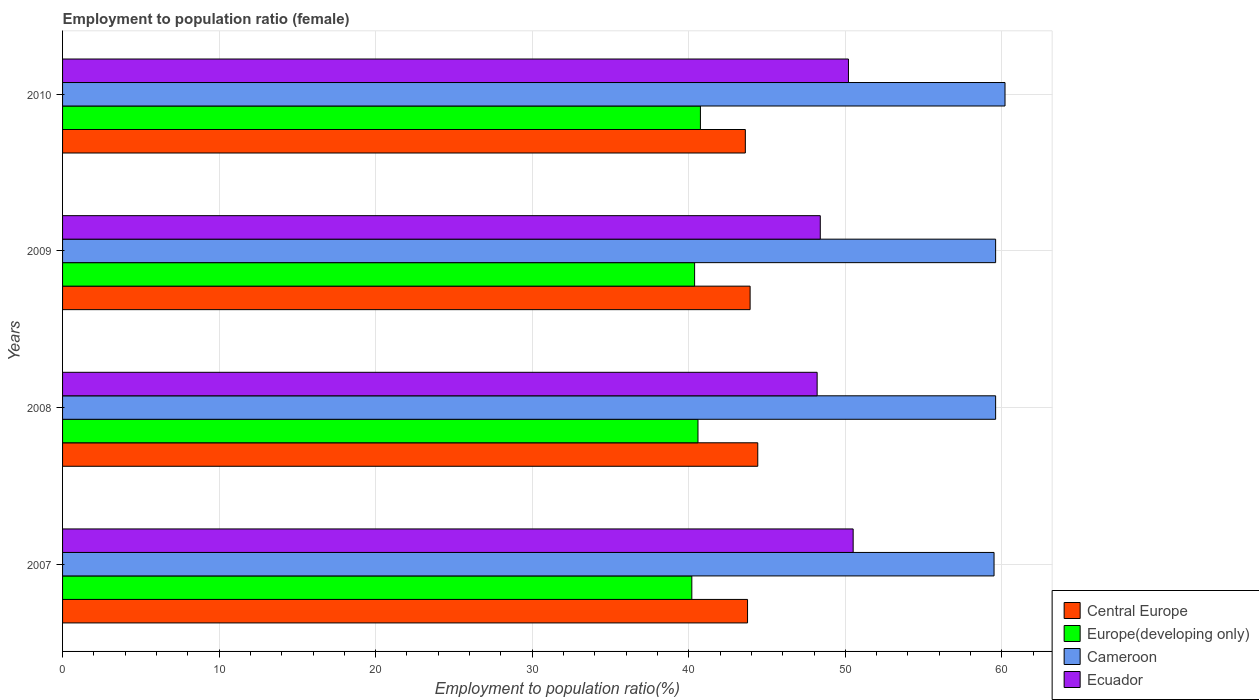How many groups of bars are there?
Your answer should be very brief. 4. Are the number of bars per tick equal to the number of legend labels?
Give a very brief answer. Yes. Are the number of bars on each tick of the Y-axis equal?
Keep it short and to the point. Yes. How many bars are there on the 2nd tick from the bottom?
Provide a short and direct response. 4. In how many cases, is the number of bars for a given year not equal to the number of legend labels?
Your answer should be compact. 0. What is the employment to population ratio in Cameroon in 2010?
Give a very brief answer. 60.2. Across all years, what is the maximum employment to population ratio in Central Europe?
Make the answer very short. 44.41. Across all years, what is the minimum employment to population ratio in Ecuador?
Offer a terse response. 48.2. In which year was the employment to population ratio in Cameroon maximum?
Give a very brief answer. 2010. In which year was the employment to population ratio in Ecuador minimum?
Offer a very short reply. 2008. What is the total employment to population ratio in Central Europe in the graph?
Your answer should be very brief. 175.69. What is the difference between the employment to population ratio in Central Europe in 2007 and that in 2010?
Keep it short and to the point. 0.14. What is the difference between the employment to population ratio in Cameroon in 2009 and the employment to population ratio in Europe(developing only) in 2007?
Keep it short and to the point. 19.41. What is the average employment to population ratio in Central Europe per year?
Your answer should be very brief. 43.92. In the year 2007, what is the difference between the employment to population ratio in Ecuador and employment to population ratio in Europe(developing only)?
Your answer should be very brief. 10.31. What is the ratio of the employment to population ratio in Cameroon in 2008 to that in 2010?
Keep it short and to the point. 0.99. Is the employment to population ratio in Central Europe in 2008 less than that in 2010?
Give a very brief answer. No. Is the difference between the employment to population ratio in Ecuador in 2007 and 2009 greater than the difference between the employment to population ratio in Europe(developing only) in 2007 and 2009?
Your answer should be very brief. Yes. What is the difference between the highest and the second highest employment to population ratio in Cameroon?
Offer a very short reply. 0.6. What is the difference between the highest and the lowest employment to population ratio in Cameroon?
Your answer should be very brief. 0.7. In how many years, is the employment to population ratio in Cameroon greater than the average employment to population ratio in Cameroon taken over all years?
Provide a short and direct response. 1. Is the sum of the employment to population ratio in Cameroon in 2007 and 2009 greater than the maximum employment to population ratio in Europe(developing only) across all years?
Keep it short and to the point. Yes. Is it the case that in every year, the sum of the employment to population ratio in Cameroon and employment to population ratio in Ecuador is greater than the sum of employment to population ratio in Europe(developing only) and employment to population ratio in Central Europe?
Your answer should be compact. Yes. What does the 2nd bar from the top in 2007 represents?
Ensure brevity in your answer.  Cameroon. What does the 1st bar from the bottom in 2010 represents?
Ensure brevity in your answer.  Central Europe. Is it the case that in every year, the sum of the employment to population ratio in Europe(developing only) and employment to population ratio in Central Europe is greater than the employment to population ratio in Ecuador?
Give a very brief answer. Yes. How many bars are there?
Ensure brevity in your answer.  16. What is the difference between two consecutive major ticks on the X-axis?
Your response must be concise. 10. Does the graph contain any zero values?
Provide a short and direct response. No. Where does the legend appear in the graph?
Give a very brief answer. Bottom right. How many legend labels are there?
Provide a short and direct response. 4. What is the title of the graph?
Your answer should be very brief. Employment to population ratio (female). What is the label or title of the X-axis?
Make the answer very short. Employment to population ratio(%). What is the Employment to population ratio(%) in Central Europe in 2007?
Keep it short and to the point. 43.75. What is the Employment to population ratio(%) in Europe(developing only) in 2007?
Keep it short and to the point. 40.19. What is the Employment to population ratio(%) of Cameroon in 2007?
Keep it short and to the point. 59.5. What is the Employment to population ratio(%) in Ecuador in 2007?
Offer a terse response. 50.5. What is the Employment to population ratio(%) in Central Europe in 2008?
Provide a short and direct response. 44.41. What is the Employment to population ratio(%) in Europe(developing only) in 2008?
Make the answer very short. 40.59. What is the Employment to population ratio(%) in Cameroon in 2008?
Ensure brevity in your answer.  59.6. What is the Employment to population ratio(%) of Ecuador in 2008?
Keep it short and to the point. 48.2. What is the Employment to population ratio(%) of Central Europe in 2009?
Offer a very short reply. 43.92. What is the Employment to population ratio(%) in Europe(developing only) in 2009?
Offer a terse response. 40.37. What is the Employment to population ratio(%) in Cameroon in 2009?
Give a very brief answer. 59.6. What is the Employment to population ratio(%) of Ecuador in 2009?
Offer a terse response. 48.4. What is the Employment to population ratio(%) of Central Europe in 2010?
Your answer should be compact. 43.61. What is the Employment to population ratio(%) of Europe(developing only) in 2010?
Offer a terse response. 40.74. What is the Employment to population ratio(%) in Cameroon in 2010?
Keep it short and to the point. 60.2. What is the Employment to population ratio(%) of Ecuador in 2010?
Keep it short and to the point. 50.2. Across all years, what is the maximum Employment to population ratio(%) of Central Europe?
Provide a short and direct response. 44.41. Across all years, what is the maximum Employment to population ratio(%) of Europe(developing only)?
Your answer should be compact. 40.74. Across all years, what is the maximum Employment to population ratio(%) of Cameroon?
Keep it short and to the point. 60.2. Across all years, what is the maximum Employment to population ratio(%) of Ecuador?
Give a very brief answer. 50.5. Across all years, what is the minimum Employment to population ratio(%) of Central Europe?
Offer a very short reply. 43.61. Across all years, what is the minimum Employment to population ratio(%) of Europe(developing only)?
Give a very brief answer. 40.19. Across all years, what is the minimum Employment to population ratio(%) in Cameroon?
Provide a succinct answer. 59.5. Across all years, what is the minimum Employment to population ratio(%) of Ecuador?
Offer a terse response. 48.2. What is the total Employment to population ratio(%) in Central Europe in the graph?
Provide a short and direct response. 175.69. What is the total Employment to population ratio(%) in Europe(developing only) in the graph?
Keep it short and to the point. 161.9. What is the total Employment to population ratio(%) of Cameroon in the graph?
Your answer should be compact. 238.9. What is the total Employment to population ratio(%) of Ecuador in the graph?
Offer a terse response. 197.3. What is the difference between the Employment to population ratio(%) in Central Europe in 2007 and that in 2008?
Ensure brevity in your answer.  -0.65. What is the difference between the Employment to population ratio(%) of Europe(developing only) in 2007 and that in 2008?
Make the answer very short. -0.39. What is the difference between the Employment to population ratio(%) of Cameroon in 2007 and that in 2008?
Your response must be concise. -0.1. What is the difference between the Employment to population ratio(%) of Ecuador in 2007 and that in 2008?
Provide a succinct answer. 2.3. What is the difference between the Employment to population ratio(%) of Central Europe in 2007 and that in 2009?
Give a very brief answer. -0.16. What is the difference between the Employment to population ratio(%) of Europe(developing only) in 2007 and that in 2009?
Your answer should be very brief. -0.18. What is the difference between the Employment to population ratio(%) in Cameroon in 2007 and that in 2009?
Provide a short and direct response. -0.1. What is the difference between the Employment to population ratio(%) of Central Europe in 2007 and that in 2010?
Provide a succinct answer. 0.14. What is the difference between the Employment to population ratio(%) in Europe(developing only) in 2007 and that in 2010?
Ensure brevity in your answer.  -0.55. What is the difference between the Employment to population ratio(%) in Cameroon in 2007 and that in 2010?
Your answer should be very brief. -0.7. What is the difference between the Employment to population ratio(%) of Central Europe in 2008 and that in 2009?
Your response must be concise. 0.49. What is the difference between the Employment to population ratio(%) in Europe(developing only) in 2008 and that in 2009?
Make the answer very short. 0.22. What is the difference between the Employment to population ratio(%) of Cameroon in 2008 and that in 2009?
Keep it short and to the point. 0. What is the difference between the Employment to population ratio(%) of Ecuador in 2008 and that in 2009?
Give a very brief answer. -0.2. What is the difference between the Employment to population ratio(%) in Central Europe in 2008 and that in 2010?
Give a very brief answer. 0.79. What is the difference between the Employment to population ratio(%) in Europe(developing only) in 2008 and that in 2010?
Keep it short and to the point. -0.16. What is the difference between the Employment to population ratio(%) in Cameroon in 2008 and that in 2010?
Your answer should be compact. -0.6. What is the difference between the Employment to population ratio(%) of Central Europe in 2009 and that in 2010?
Your answer should be very brief. 0.3. What is the difference between the Employment to population ratio(%) of Europe(developing only) in 2009 and that in 2010?
Offer a terse response. -0.37. What is the difference between the Employment to population ratio(%) in Cameroon in 2009 and that in 2010?
Your answer should be compact. -0.6. What is the difference between the Employment to population ratio(%) of Central Europe in 2007 and the Employment to population ratio(%) of Europe(developing only) in 2008?
Offer a terse response. 3.17. What is the difference between the Employment to population ratio(%) of Central Europe in 2007 and the Employment to population ratio(%) of Cameroon in 2008?
Your answer should be very brief. -15.85. What is the difference between the Employment to population ratio(%) of Central Europe in 2007 and the Employment to population ratio(%) of Ecuador in 2008?
Make the answer very short. -4.45. What is the difference between the Employment to population ratio(%) in Europe(developing only) in 2007 and the Employment to population ratio(%) in Cameroon in 2008?
Ensure brevity in your answer.  -19.41. What is the difference between the Employment to population ratio(%) in Europe(developing only) in 2007 and the Employment to population ratio(%) in Ecuador in 2008?
Your answer should be very brief. -8.01. What is the difference between the Employment to population ratio(%) in Cameroon in 2007 and the Employment to population ratio(%) in Ecuador in 2008?
Ensure brevity in your answer.  11.3. What is the difference between the Employment to population ratio(%) in Central Europe in 2007 and the Employment to population ratio(%) in Europe(developing only) in 2009?
Your response must be concise. 3.38. What is the difference between the Employment to population ratio(%) in Central Europe in 2007 and the Employment to population ratio(%) in Cameroon in 2009?
Keep it short and to the point. -15.85. What is the difference between the Employment to population ratio(%) in Central Europe in 2007 and the Employment to population ratio(%) in Ecuador in 2009?
Keep it short and to the point. -4.65. What is the difference between the Employment to population ratio(%) in Europe(developing only) in 2007 and the Employment to population ratio(%) in Cameroon in 2009?
Offer a very short reply. -19.41. What is the difference between the Employment to population ratio(%) in Europe(developing only) in 2007 and the Employment to population ratio(%) in Ecuador in 2009?
Make the answer very short. -8.21. What is the difference between the Employment to population ratio(%) in Central Europe in 2007 and the Employment to population ratio(%) in Europe(developing only) in 2010?
Keep it short and to the point. 3.01. What is the difference between the Employment to population ratio(%) of Central Europe in 2007 and the Employment to population ratio(%) of Cameroon in 2010?
Keep it short and to the point. -16.45. What is the difference between the Employment to population ratio(%) in Central Europe in 2007 and the Employment to population ratio(%) in Ecuador in 2010?
Provide a short and direct response. -6.45. What is the difference between the Employment to population ratio(%) of Europe(developing only) in 2007 and the Employment to population ratio(%) of Cameroon in 2010?
Keep it short and to the point. -20.01. What is the difference between the Employment to population ratio(%) of Europe(developing only) in 2007 and the Employment to population ratio(%) of Ecuador in 2010?
Provide a succinct answer. -10.01. What is the difference between the Employment to population ratio(%) of Cameroon in 2007 and the Employment to population ratio(%) of Ecuador in 2010?
Ensure brevity in your answer.  9.3. What is the difference between the Employment to population ratio(%) in Central Europe in 2008 and the Employment to population ratio(%) in Europe(developing only) in 2009?
Ensure brevity in your answer.  4.03. What is the difference between the Employment to population ratio(%) of Central Europe in 2008 and the Employment to population ratio(%) of Cameroon in 2009?
Offer a very short reply. -15.19. What is the difference between the Employment to population ratio(%) in Central Europe in 2008 and the Employment to population ratio(%) in Ecuador in 2009?
Provide a succinct answer. -3.99. What is the difference between the Employment to population ratio(%) in Europe(developing only) in 2008 and the Employment to population ratio(%) in Cameroon in 2009?
Your response must be concise. -19.01. What is the difference between the Employment to population ratio(%) of Europe(developing only) in 2008 and the Employment to population ratio(%) of Ecuador in 2009?
Provide a succinct answer. -7.81. What is the difference between the Employment to population ratio(%) of Central Europe in 2008 and the Employment to population ratio(%) of Europe(developing only) in 2010?
Provide a succinct answer. 3.66. What is the difference between the Employment to population ratio(%) in Central Europe in 2008 and the Employment to population ratio(%) in Cameroon in 2010?
Provide a succinct answer. -15.79. What is the difference between the Employment to population ratio(%) in Central Europe in 2008 and the Employment to population ratio(%) in Ecuador in 2010?
Offer a terse response. -5.79. What is the difference between the Employment to population ratio(%) in Europe(developing only) in 2008 and the Employment to population ratio(%) in Cameroon in 2010?
Your response must be concise. -19.61. What is the difference between the Employment to population ratio(%) in Europe(developing only) in 2008 and the Employment to population ratio(%) in Ecuador in 2010?
Your answer should be very brief. -9.61. What is the difference between the Employment to population ratio(%) in Cameroon in 2008 and the Employment to population ratio(%) in Ecuador in 2010?
Your answer should be compact. 9.4. What is the difference between the Employment to population ratio(%) in Central Europe in 2009 and the Employment to population ratio(%) in Europe(developing only) in 2010?
Give a very brief answer. 3.17. What is the difference between the Employment to population ratio(%) in Central Europe in 2009 and the Employment to population ratio(%) in Cameroon in 2010?
Provide a succinct answer. -16.28. What is the difference between the Employment to population ratio(%) of Central Europe in 2009 and the Employment to population ratio(%) of Ecuador in 2010?
Offer a terse response. -6.28. What is the difference between the Employment to population ratio(%) of Europe(developing only) in 2009 and the Employment to population ratio(%) of Cameroon in 2010?
Provide a succinct answer. -19.83. What is the difference between the Employment to population ratio(%) in Europe(developing only) in 2009 and the Employment to population ratio(%) in Ecuador in 2010?
Your answer should be compact. -9.83. What is the average Employment to population ratio(%) of Central Europe per year?
Keep it short and to the point. 43.92. What is the average Employment to population ratio(%) of Europe(developing only) per year?
Keep it short and to the point. 40.47. What is the average Employment to population ratio(%) of Cameroon per year?
Offer a very short reply. 59.73. What is the average Employment to population ratio(%) of Ecuador per year?
Your answer should be compact. 49.33. In the year 2007, what is the difference between the Employment to population ratio(%) of Central Europe and Employment to population ratio(%) of Europe(developing only)?
Provide a short and direct response. 3.56. In the year 2007, what is the difference between the Employment to population ratio(%) of Central Europe and Employment to population ratio(%) of Cameroon?
Offer a very short reply. -15.75. In the year 2007, what is the difference between the Employment to population ratio(%) of Central Europe and Employment to population ratio(%) of Ecuador?
Give a very brief answer. -6.75. In the year 2007, what is the difference between the Employment to population ratio(%) of Europe(developing only) and Employment to population ratio(%) of Cameroon?
Give a very brief answer. -19.31. In the year 2007, what is the difference between the Employment to population ratio(%) of Europe(developing only) and Employment to population ratio(%) of Ecuador?
Offer a terse response. -10.31. In the year 2007, what is the difference between the Employment to population ratio(%) of Cameroon and Employment to population ratio(%) of Ecuador?
Offer a terse response. 9. In the year 2008, what is the difference between the Employment to population ratio(%) in Central Europe and Employment to population ratio(%) in Europe(developing only)?
Make the answer very short. 3.82. In the year 2008, what is the difference between the Employment to population ratio(%) of Central Europe and Employment to population ratio(%) of Cameroon?
Your response must be concise. -15.19. In the year 2008, what is the difference between the Employment to population ratio(%) of Central Europe and Employment to population ratio(%) of Ecuador?
Give a very brief answer. -3.79. In the year 2008, what is the difference between the Employment to population ratio(%) of Europe(developing only) and Employment to population ratio(%) of Cameroon?
Your answer should be very brief. -19.01. In the year 2008, what is the difference between the Employment to population ratio(%) of Europe(developing only) and Employment to population ratio(%) of Ecuador?
Your answer should be very brief. -7.61. In the year 2009, what is the difference between the Employment to population ratio(%) in Central Europe and Employment to population ratio(%) in Europe(developing only)?
Ensure brevity in your answer.  3.55. In the year 2009, what is the difference between the Employment to population ratio(%) in Central Europe and Employment to population ratio(%) in Cameroon?
Your answer should be compact. -15.68. In the year 2009, what is the difference between the Employment to population ratio(%) in Central Europe and Employment to population ratio(%) in Ecuador?
Provide a short and direct response. -4.48. In the year 2009, what is the difference between the Employment to population ratio(%) of Europe(developing only) and Employment to population ratio(%) of Cameroon?
Your response must be concise. -19.23. In the year 2009, what is the difference between the Employment to population ratio(%) of Europe(developing only) and Employment to population ratio(%) of Ecuador?
Provide a short and direct response. -8.03. In the year 2009, what is the difference between the Employment to population ratio(%) of Cameroon and Employment to population ratio(%) of Ecuador?
Keep it short and to the point. 11.2. In the year 2010, what is the difference between the Employment to population ratio(%) of Central Europe and Employment to population ratio(%) of Europe(developing only)?
Your response must be concise. 2.87. In the year 2010, what is the difference between the Employment to population ratio(%) of Central Europe and Employment to population ratio(%) of Cameroon?
Your answer should be very brief. -16.59. In the year 2010, what is the difference between the Employment to population ratio(%) in Central Europe and Employment to population ratio(%) in Ecuador?
Offer a very short reply. -6.59. In the year 2010, what is the difference between the Employment to population ratio(%) of Europe(developing only) and Employment to population ratio(%) of Cameroon?
Provide a short and direct response. -19.46. In the year 2010, what is the difference between the Employment to population ratio(%) of Europe(developing only) and Employment to population ratio(%) of Ecuador?
Your answer should be compact. -9.46. In the year 2010, what is the difference between the Employment to population ratio(%) of Cameroon and Employment to population ratio(%) of Ecuador?
Make the answer very short. 10. What is the ratio of the Employment to population ratio(%) of Europe(developing only) in 2007 to that in 2008?
Ensure brevity in your answer.  0.99. What is the ratio of the Employment to population ratio(%) of Ecuador in 2007 to that in 2008?
Your answer should be compact. 1.05. What is the ratio of the Employment to population ratio(%) in Central Europe in 2007 to that in 2009?
Your answer should be compact. 1. What is the ratio of the Employment to population ratio(%) in Cameroon in 2007 to that in 2009?
Give a very brief answer. 1. What is the ratio of the Employment to population ratio(%) of Ecuador in 2007 to that in 2009?
Offer a terse response. 1.04. What is the ratio of the Employment to population ratio(%) in Central Europe in 2007 to that in 2010?
Offer a very short reply. 1. What is the ratio of the Employment to population ratio(%) in Europe(developing only) in 2007 to that in 2010?
Provide a succinct answer. 0.99. What is the ratio of the Employment to population ratio(%) of Cameroon in 2007 to that in 2010?
Offer a very short reply. 0.99. What is the ratio of the Employment to population ratio(%) in Central Europe in 2008 to that in 2009?
Your answer should be compact. 1.01. What is the ratio of the Employment to population ratio(%) in Europe(developing only) in 2008 to that in 2009?
Provide a short and direct response. 1.01. What is the ratio of the Employment to population ratio(%) of Central Europe in 2008 to that in 2010?
Make the answer very short. 1.02. What is the ratio of the Employment to population ratio(%) in Ecuador in 2008 to that in 2010?
Ensure brevity in your answer.  0.96. What is the ratio of the Employment to population ratio(%) in Central Europe in 2009 to that in 2010?
Your response must be concise. 1.01. What is the ratio of the Employment to population ratio(%) in Europe(developing only) in 2009 to that in 2010?
Your answer should be compact. 0.99. What is the ratio of the Employment to population ratio(%) of Ecuador in 2009 to that in 2010?
Your answer should be very brief. 0.96. What is the difference between the highest and the second highest Employment to population ratio(%) in Central Europe?
Your response must be concise. 0.49. What is the difference between the highest and the second highest Employment to population ratio(%) of Europe(developing only)?
Your answer should be very brief. 0.16. What is the difference between the highest and the lowest Employment to population ratio(%) in Central Europe?
Your answer should be compact. 0.79. What is the difference between the highest and the lowest Employment to population ratio(%) in Europe(developing only)?
Your answer should be very brief. 0.55. What is the difference between the highest and the lowest Employment to population ratio(%) in Ecuador?
Provide a succinct answer. 2.3. 